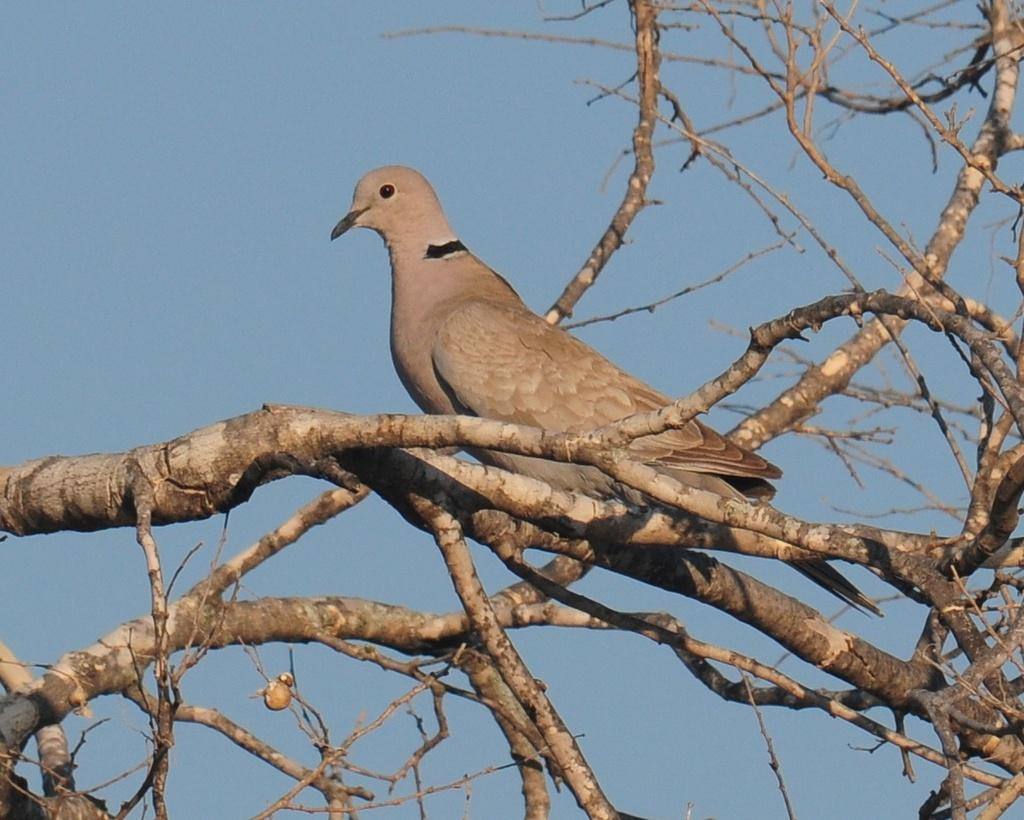What type of animal is on the tree in the image? There is a bird on the tree in the image. How would you describe the tree's appearance? The tree has dried branches. What can be seen in the background of the image? The sky is visible in the background of the image. What is the color of the sky in the image? The color of the sky is blue. What type of crime is being committed by the cloud in the image? There is no cloud or crime present in the image; it features a bird on a tree with a blue sky in the background. 